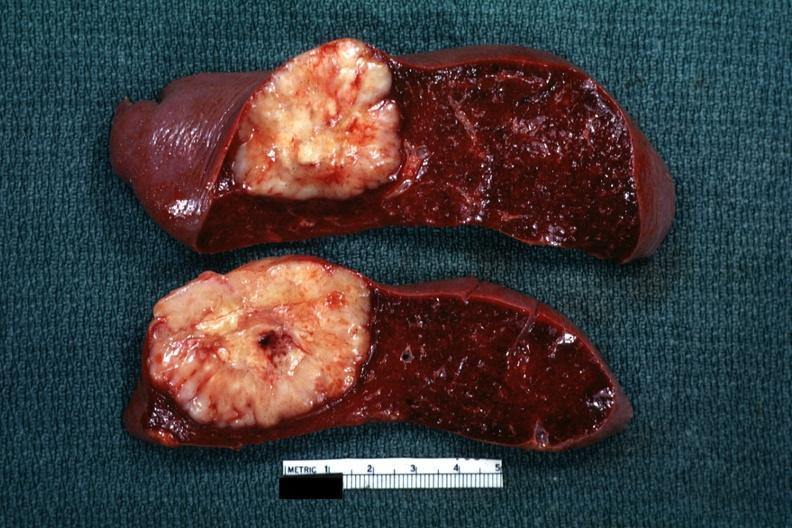does ameloblastoma show single metastatic appearing lesion is quite large diagnosis was reticulum cell sarcoma?
Answer the question using a single word or phrase. No 